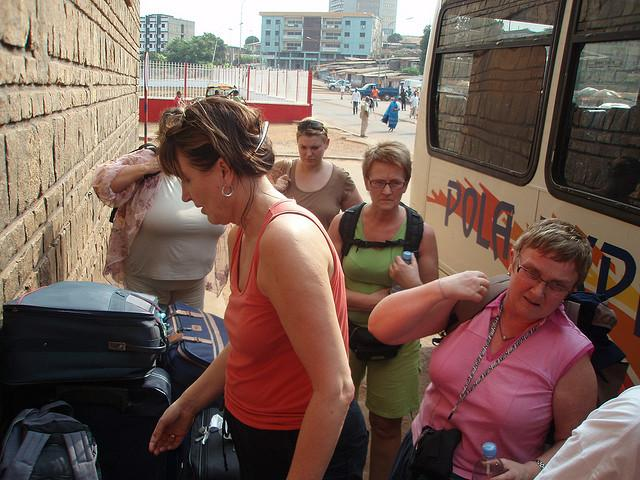What are the buildings in the background likely used for?

Choices:
A) offices
B) private dwellings
C) shops
D) schools private dwellings 